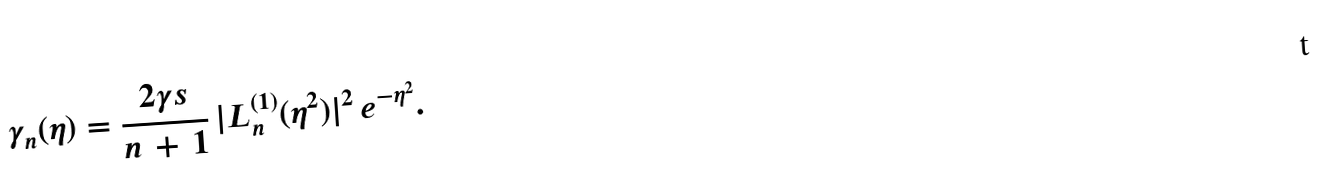Convert formula to latex. <formula><loc_0><loc_0><loc_500><loc_500>\gamma _ { n } ( \eta ) = \frac { 2 \gamma s } { n \, + \, 1 } \, | L _ { n } ^ { ( 1 ) } ( \eta ^ { 2 } ) | ^ { 2 } \, e ^ { - \eta ^ { 2 } } .</formula> 